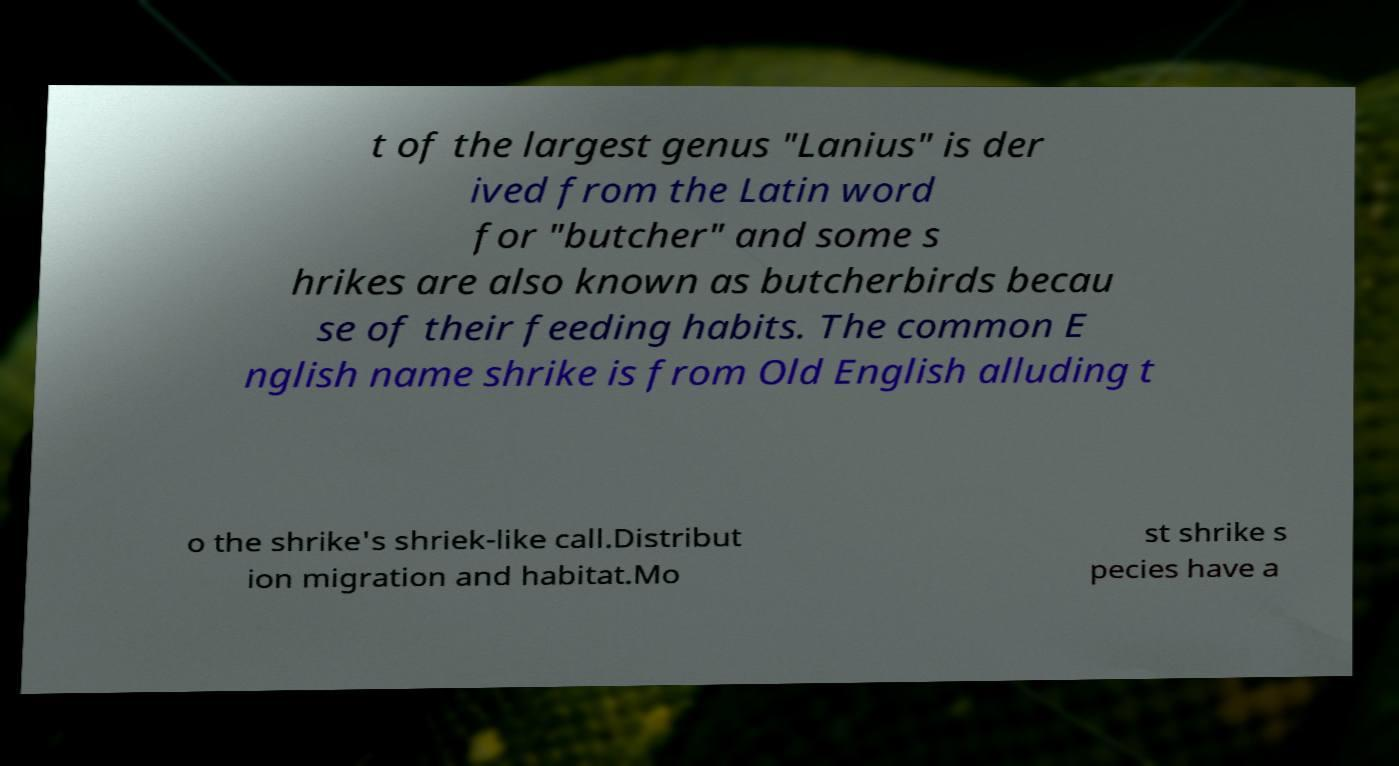What messages or text are displayed in this image? I need them in a readable, typed format. t of the largest genus "Lanius" is der ived from the Latin word for "butcher" and some s hrikes are also known as butcherbirds becau se of their feeding habits. The common E nglish name shrike is from Old English alluding t o the shrike's shriek-like call.Distribut ion migration and habitat.Mo st shrike s pecies have a 